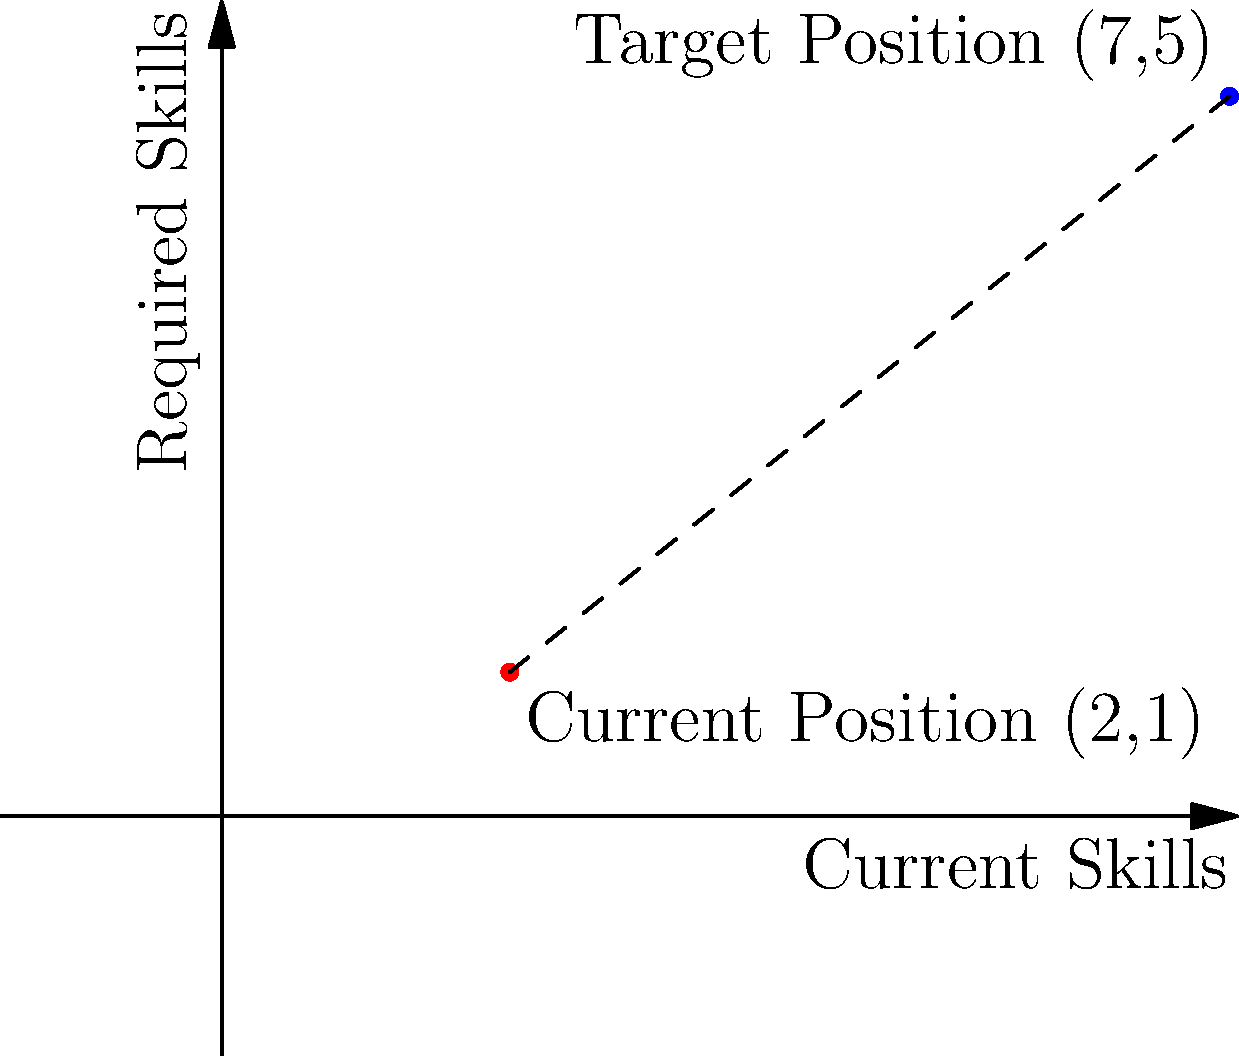As a CEO transitioning to a new industry, you've mapped your current skill set and the required skills for your target position on a 2D graph. Your current skill position is at point A(2,1), and the target skill position is at point B(7,5). Using the distance formula, calculate the skill gap you need to bridge to reach your target position. Round your answer to two decimal places. To solve this problem, we'll use the distance formula between two points in a 2D plane:

$$d = \sqrt{(x_2 - x_1)^2 + (y_2 - y_1)^2}$$

Where $(x_1, y_1)$ represents the coordinates of the first point and $(x_2, y_2)$ represents the coordinates of the second point.

Step 1: Identify the coordinates
Point A (current skills): $(x_1, y_1) = (2, 1)$
Point B (required skills): $(x_2, y_2) = (7, 5)$

Step 2: Plug the values into the distance formula
$$d = \sqrt{(7 - 2)^2 + (5 - 1)^2}$$

Step 3: Simplify the expressions inside the parentheses
$$d = \sqrt{5^2 + 4^2}$$

Step 4: Calculate the squares
$$d = \sqrt{25 + 16}$$

Step 5: Add the values under the square root
$$d = \sqrt{41}$$

Step 6: Calculate the square root and round to two decimal places
$$d \approx 6.40$$

This value represents the skill gap you need to bridge to reach your target position in the new industry.
Answer: 6.40 